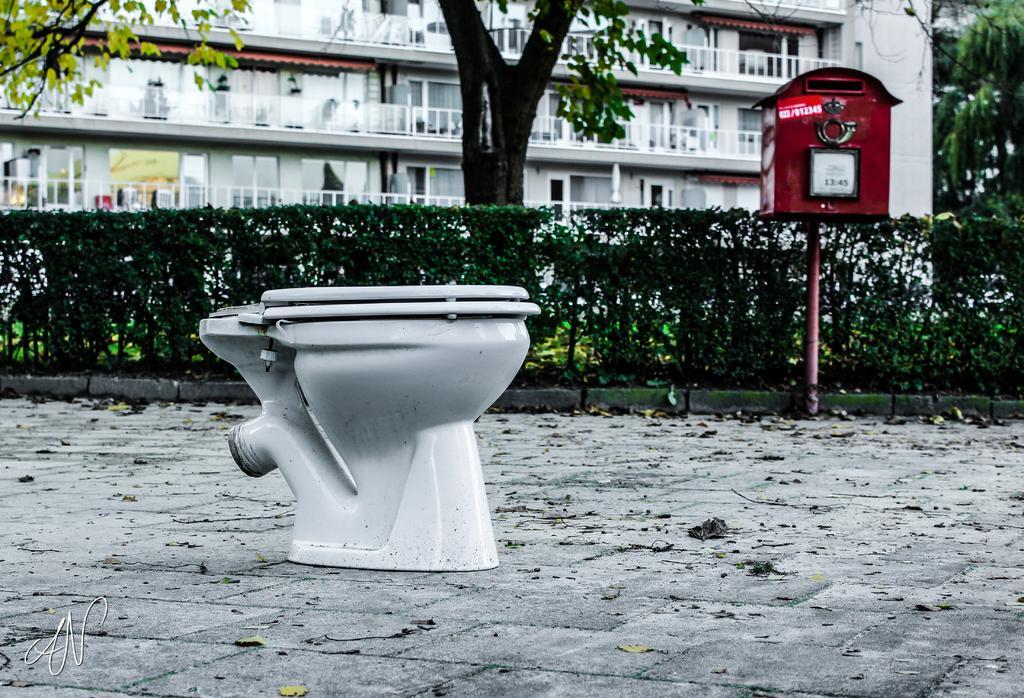Describe this image in one or two sentences. In this image in the foreground there is a pot. In the background there are plants, letterbox, trees, buildings. On the ground there there are dried leaves. 